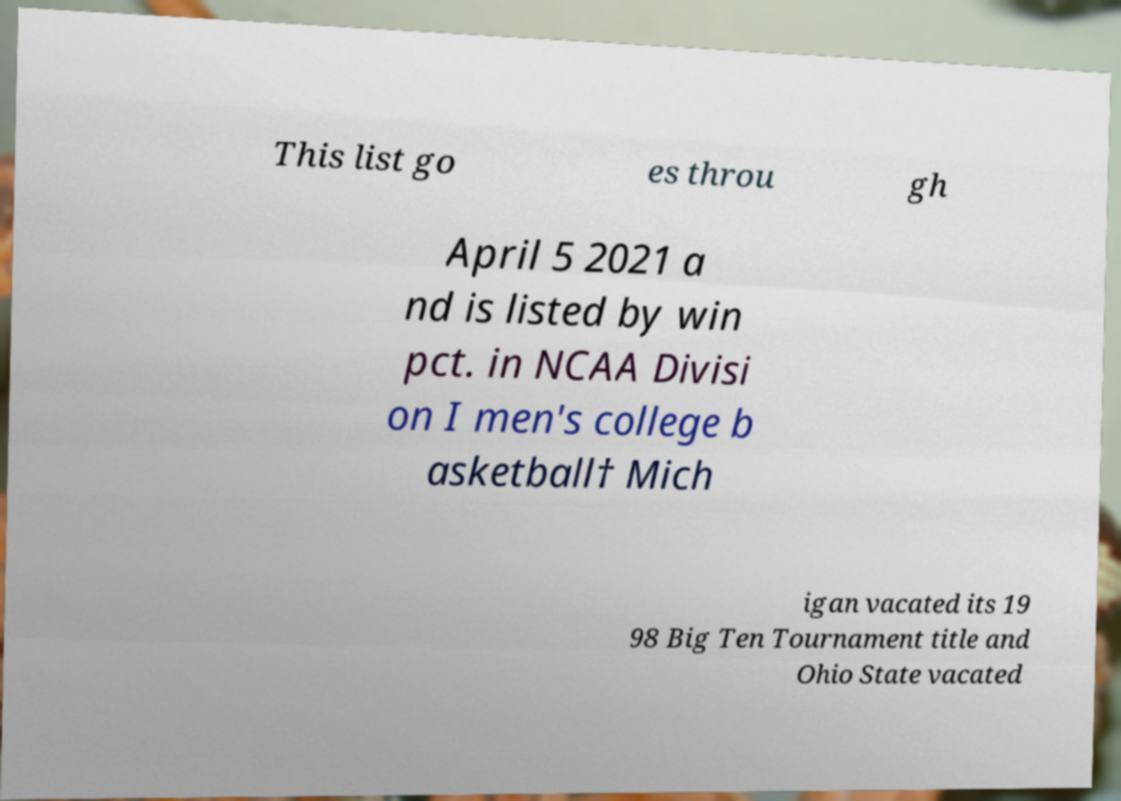Please read and relay the text visible in this image. What does it say? This list go es throu gh April 5 2021 a nd is listed by win pct. in NCAA Divisi on I men's college b asketball† Mich igan vacated its 19 98 Big Ten Tournament title and Ohio State vacated 